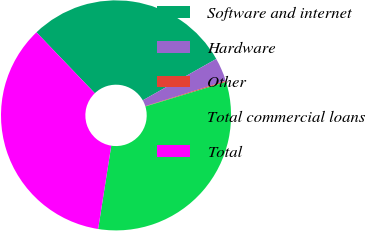Convert chart to OTSL. <chart><loc_0><loc_0><loc_500><loc_500><pie_chart><fcel>Software and internet<fcel>Hardware<fcel>Other<fcel>Total commercial loans<fcel>Total<nl><fcel>29.0%<fcel>3.32%<fcel>0.15%<fcel>32.18%<fcel>35.35%<nl></chart> 